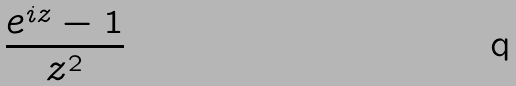<formula> <loc_0><loc_0><loc_500><loc_500>\frac { e ^ { i z } - 1 } { z ^ { 2 } }</formula> 